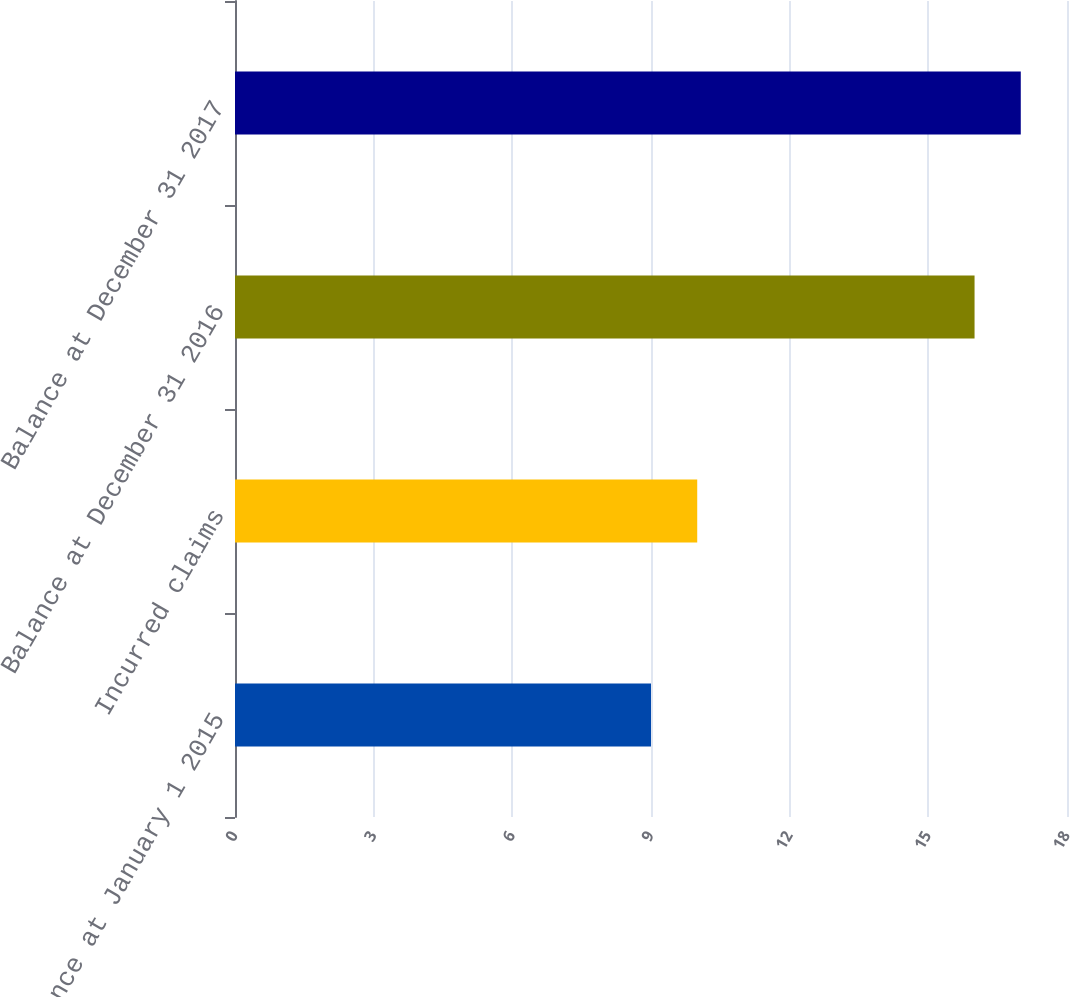Convert chart to OTSL. <chart><loc_0><loc_0><loc_500><loc_500><bar_chart><fcel>Balance at January 1 2015<fcel>Incurred claims<fcel>Balance at December 31 2016<fcel>Balance at December 31 2017<nl><fcel>9<fcel>10<fcel>16<fcel>17<nl></chart> 